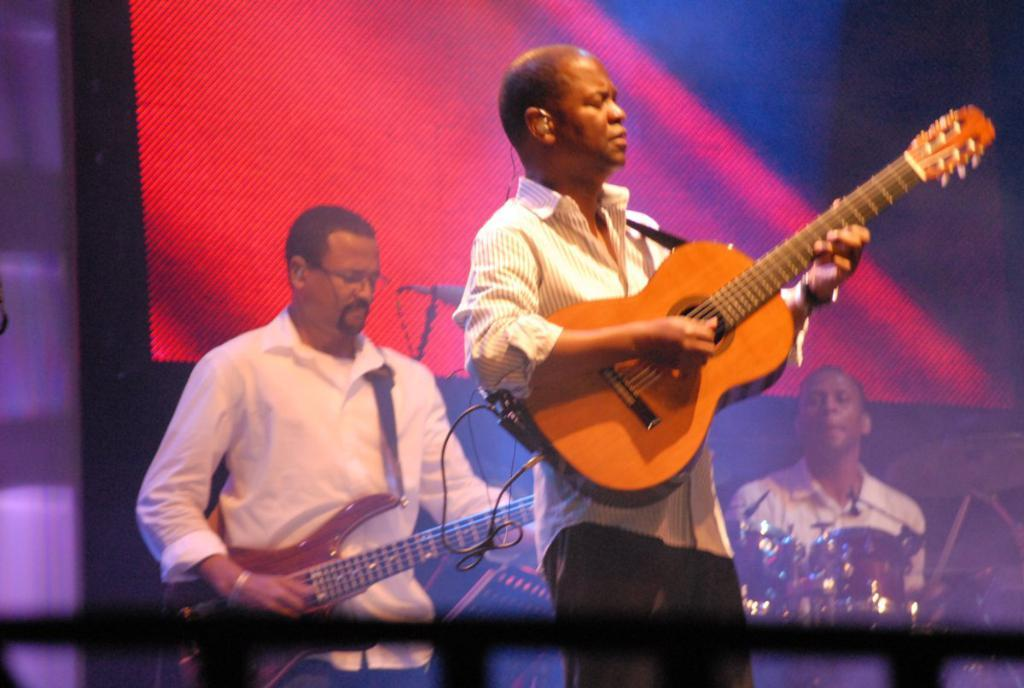What is the main activity being performed by the man in the image? The man is playing a guitar in the image. Can you describe the guitar being played by the man? The guitar is brown in color. Are there any other musicians in the image? Yes, there is another person playing a guitar behind the first man, and a person sitting far away playing musical instruments. What type of fold can be seen in the plot of the image? There is no fold or plot present in the image, as it is a photograph of people playing musical instruments. 